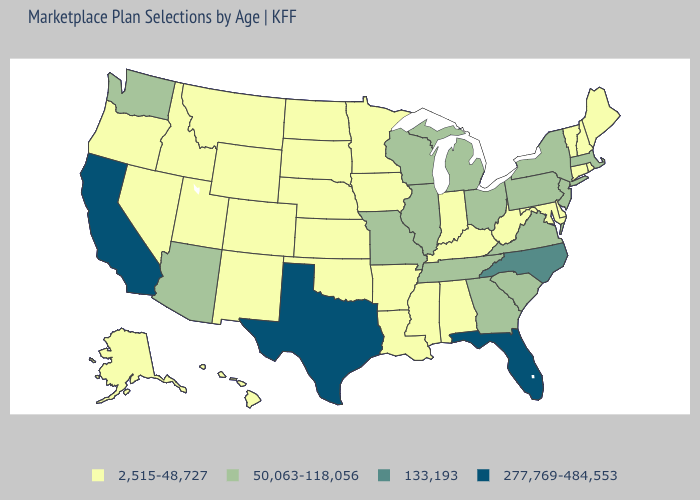Name the states that have a value in the range 133,193?
Short answer required. North Carolina. Does West Virginia have a lower value than Alaska?
Quick response, please. No. Name the states that have a value in the range 133,193?
Give a very brief answer. North Carolina. Name the states that have a value in the range 50,063-118,056?
Concise answer only. Arizona, Georgia, Illinois, Massachusetts, Michigan, Missouri, New Jersey, New York, Ohio, Pennsylvania, South Carolina, Tennessee, Virginia, Washington, Wisconsin. Name the states that have a value in the range 2,515-48,727?
Concise answer only. Alabama, Alaska, Arkansas, Colorado, Connecticut, Delaware, Hawaii, Idaho, Indiana, Iowa, Kansas, Kentucky, Louisiana, Maine, Maryland, Minnesota, Mississippi, Montana, Nebraska, Nevada, New Hampshire, New Mexico, North Dakota, Oklahoma, Oregon, Rhode Island, South Dakota, Utah, Vermont, West Virginia, Wyoming. What is the highest value in the Northeast ?
Keep it brief. 50,063-118,056. What is the lowest value in the West?
Short answer required. 2,515-48,727. Which states have the highest value in the USA?
Give a very brief answer. California, Florida, Texas. Is the legend a continuous bar?
Keep it brief. No. Which states have the highest value in the USA?
Short answer required. California, Florida, Texas. Name the states that have a value in the range 277,769-484,553?
Short answer required. California, Florida, Texas. What is the value of Ohio?
Concise answer only. 50,063-118,056. What is the lowest value in the USA?
Short answer required. 2,515-48,727. Does the first symbol in the legend represent the smallest category?
Concise answer only. Yes. Does Missouri have the highest value in the MidWest?
Concise answer only. Yes. 